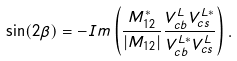Convert formula to latex. <formula><loc_0><loc_0><loc_500><loc_500>\sin ( 2 \beta ) = - I m \left ( { \frac { M _ { 1 2 } ^ { * } } { | M _ { 1 2 } | } } { \frac { V _ { c b } ^ { L } V _ { c s } ^ { L * } } { V _ { c b } ^ { L * } V _ { c s } ^ { L } } } \right ) .</formula> 